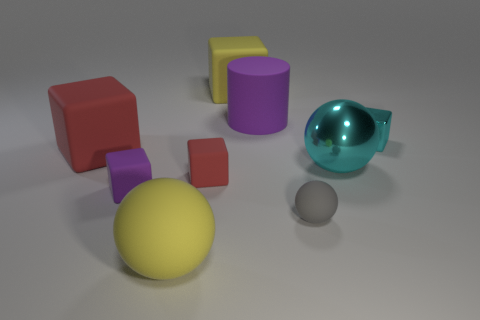Subtract 2 blocks. How many blocks are left? 3 Subtract all large red matte cubes. How many cubes are left? 4 Subtract all cyan blocks. How many blocks are left? 4 Subtract all green cubes. Subtract all red spheres. How many cubes are left? 5 Subtract all cubes. How many objects are left? 4 Subtract all shiny cylinders. Subtract all big metal objects. How many objects are left? 8 Add 1 tiny cyan shiny cubes. How many tiny cyan shiny cubes are left? 2 Add 7 yellow balls. How many yellow balls exist? 8 Subtract 0 brown cylinders. How many objects are left? 9 